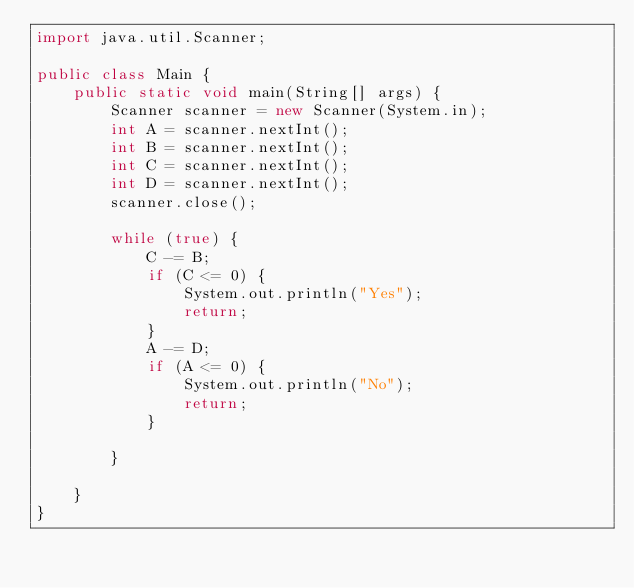Convert code to text. <code><loc_0><loc_0><loc_500><loc_500><_Java_>import java.util.Scanner;

public class Main {
    public static void main(String[] args) {
        Scanner scanner = new Scanner(System.in);
        int A = scanner.nextInt();
        int B = scanner.nextInt();
        int C = scanner.nextInt();
        int D = scanner.nextInt();
        scanner.close();

        while (true) {
            C -= B;
            if (C <= 0) {
                System.out.println("Yes");
                return;
            }
            A -= D;
            if (A <= 0) {
                System.out.println("No");
                return;
            }

        }

    }
}</code> 